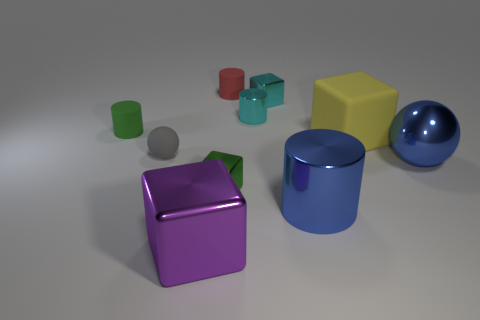Subtract all tiny cyan cylinders. How many cylinders are left? 3 Subtract all red cylinders. How many cylinders are left? 3 Subtract all cylinders. How many objects are left? 6 Add 4 small cyan objects. How many small cyan objects are left? 6 Add 5 purple shiny cubes. How many purple shiny cubes exist? 6 Subtract 0 purple balls. How many objects are left? 10 Subtract 2 cylinders. How many cylinders are left? 2 Subtract all cyan blocks. Subtract all cyan spheres. How many blocks are left? 3 Subtract all blue things. Subtract all small green rubber things. How many objects are left? 7 